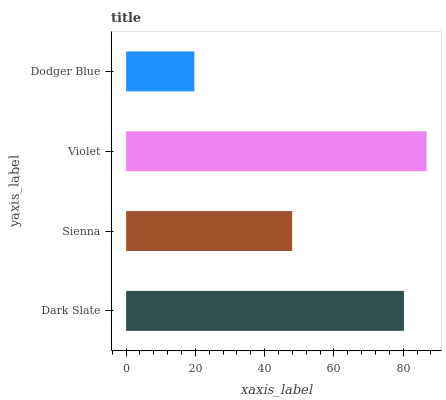Is Dodger Blue the minimum?
Answer yes or no. Yes. Is Violet the maximum?
Answer yes or no. Yes. Is Sienna the minimum?
Answer yes or no. No. Is Sienna the maximum?
Answer yes or no. No. Is Dark Slate greater than Sienna?
Answer yes or no. Yes. Is Sienna less than Dark Slate?
Answer yes or no. Yes. Is Sienna greater than Dark Slate?
Answer yes or no. No. Is Dark Slate less than Sienna?
Answer yes or no. No. Is Dark Slate the high median?
Answer yes or no. Yes. Is Sienna the low median?
Answer yes or no. Yes. Is Violet the high median?
Answer yes or no. No. Is Violet the low median?
Answer yes or no. No. 